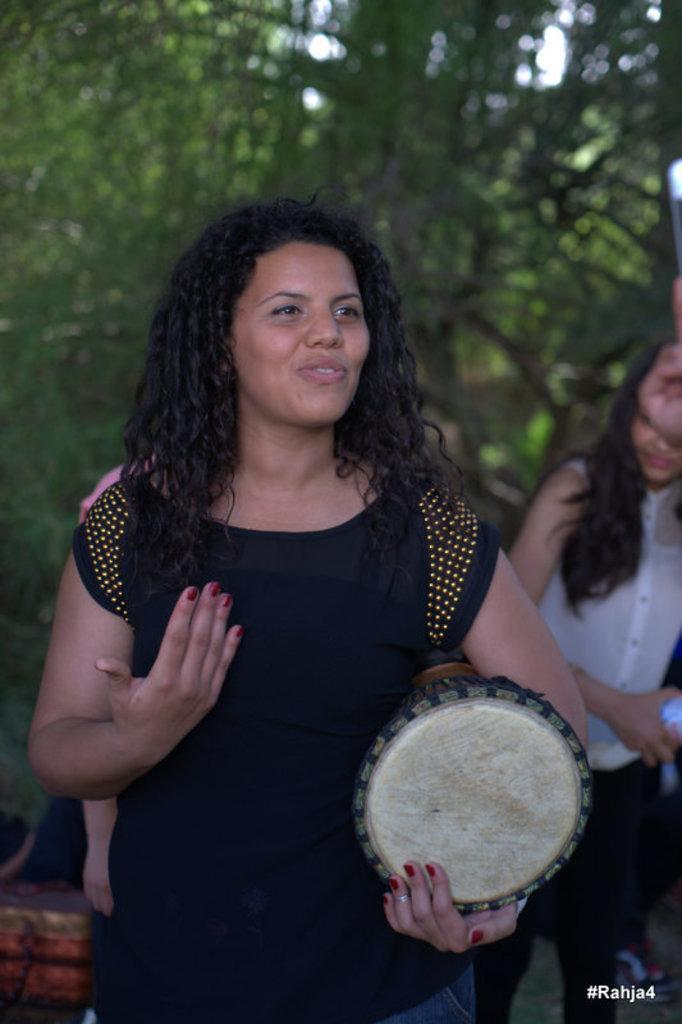In one or two sentences, can you explain what this image depicts? In this image there is a women with black dress, she is holding a musical instrument and she is smiling, at the back there is a tree. 